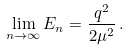<formula> <loc_0><loc_0><loc_500><loc_500>\lim _ { n \to \infty } E _ { n } = \frac { q ^ { 2 } } { 2 \mu ^ { 2 } } \, .</formula> 